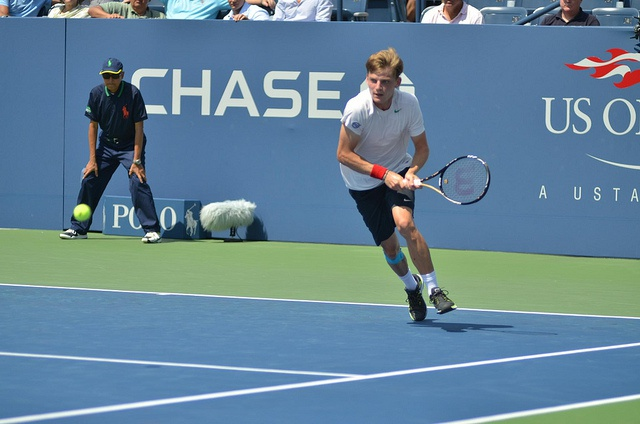Describe the objects in this image and their specific colors. I can see people in lightblue, gray, and black tones, people in lightblue, black, navy, blue, and gray tones, tennis racket in lightblue, gray, ivory, and black tones, people in lightblue, lavender, and darkgray tones, and people in lightblue and teal tones in this image. 